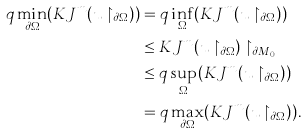Convert formula to latex. <formula><loc_0><loc_0><loc_500><loc_500>q \min _ { \partial \Omega } ( K J ^ { m } ( u \restriction _ { \partial \Omega } ) ) & = q \inf _ { \Omega } ( K J ^ { m } ( u \restriction _ { \partial \Omega } ) ) \\ & \leq K J ^ { m } ( u \restriction _ { \partial \Omega } ) \restriction _ { \partial M _ { 0 } } \\ & \leq q \sup _ { \Omega } ( K J ^ { m } ( u \restriction _ { \partial \Omega } ) ) \\ & = q \max _ { \partial \Omega } ( K J ^ { m } ( u \restriction _ { \partial \Omega } ) ) .</formula> 